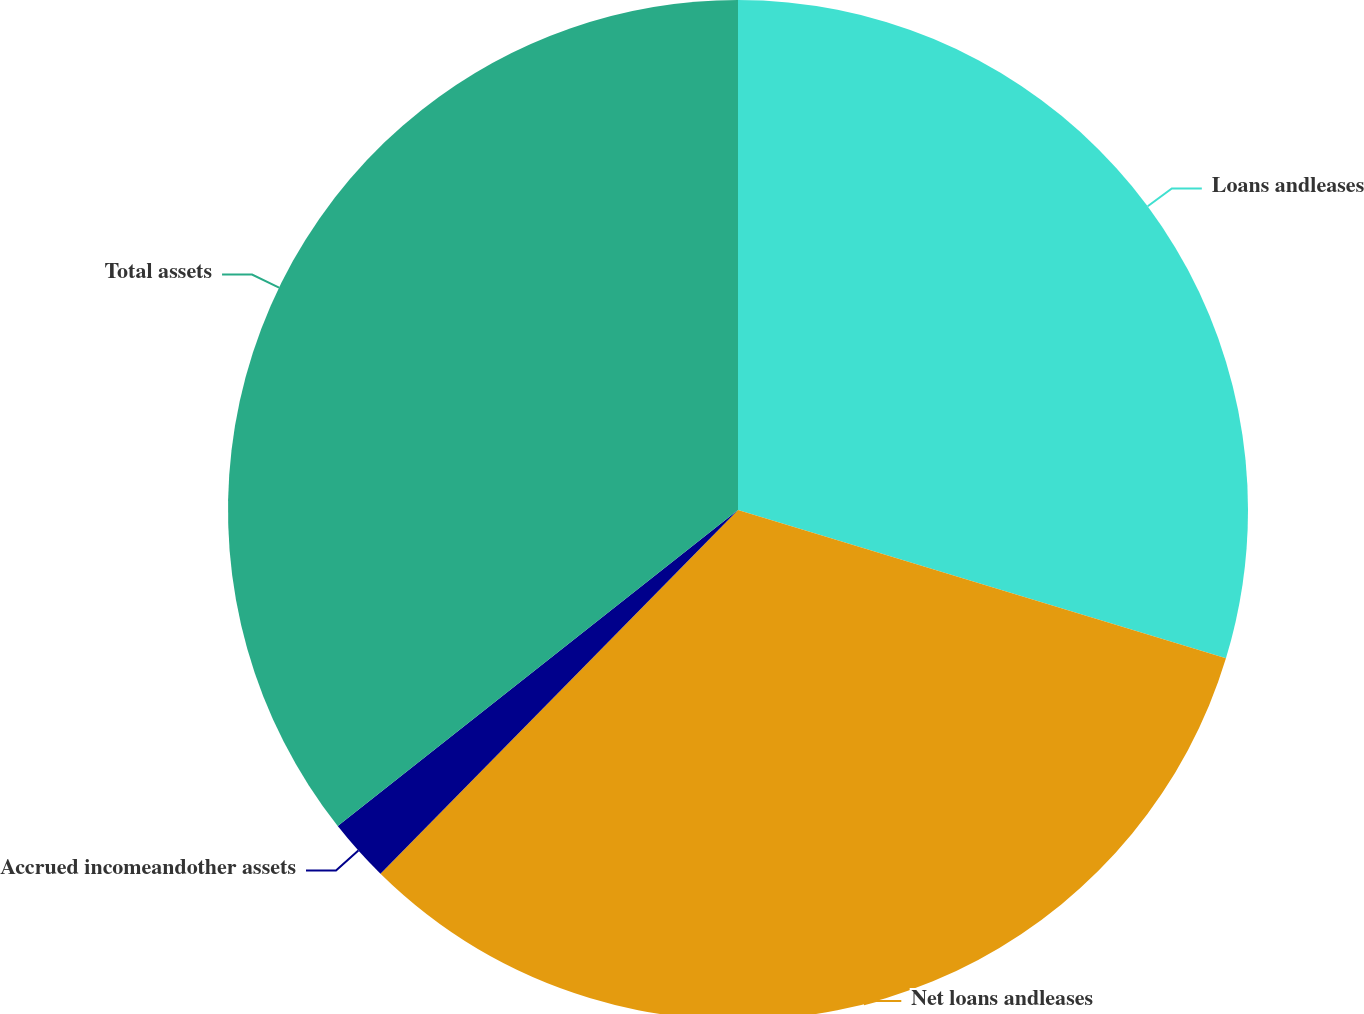Convert chart to OTSL. <chart><loc_0><loc_0><loc_500><loc_500><pie_chart><fcel>Loans andleases<fcel>Net loans andleases<fcel>Accrued incomeandother assets<fcel>Total assets<nl><fcel>29.7%<fcel>32.67%<fcel>2.0%<fcel>35.64%<nl></chart> 